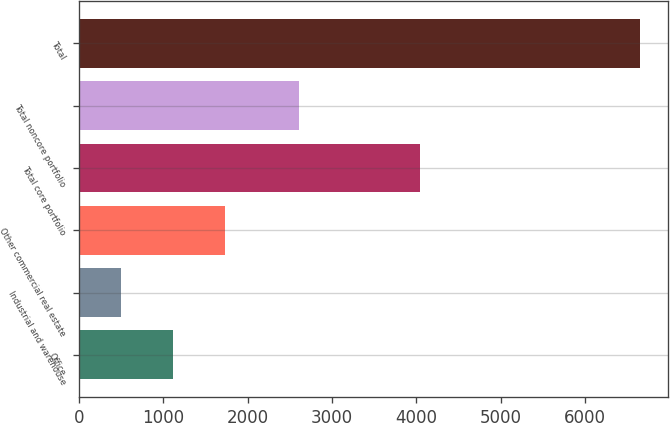Convert chart. <chart><loc_0><loc_0><loc_500><loc_500><bar_chart><fcel>Office<fcel>Industrial and warehouse<fcel>Other commercial real estate<fcel>Total core portfolio<fcel>Total noncore portfolio<fcel>Total<nl><fcel>1114.2<fcel>499<fcel>1729.4<fcel>4042<fcel>2609<fcel>6651<nl></chart> 